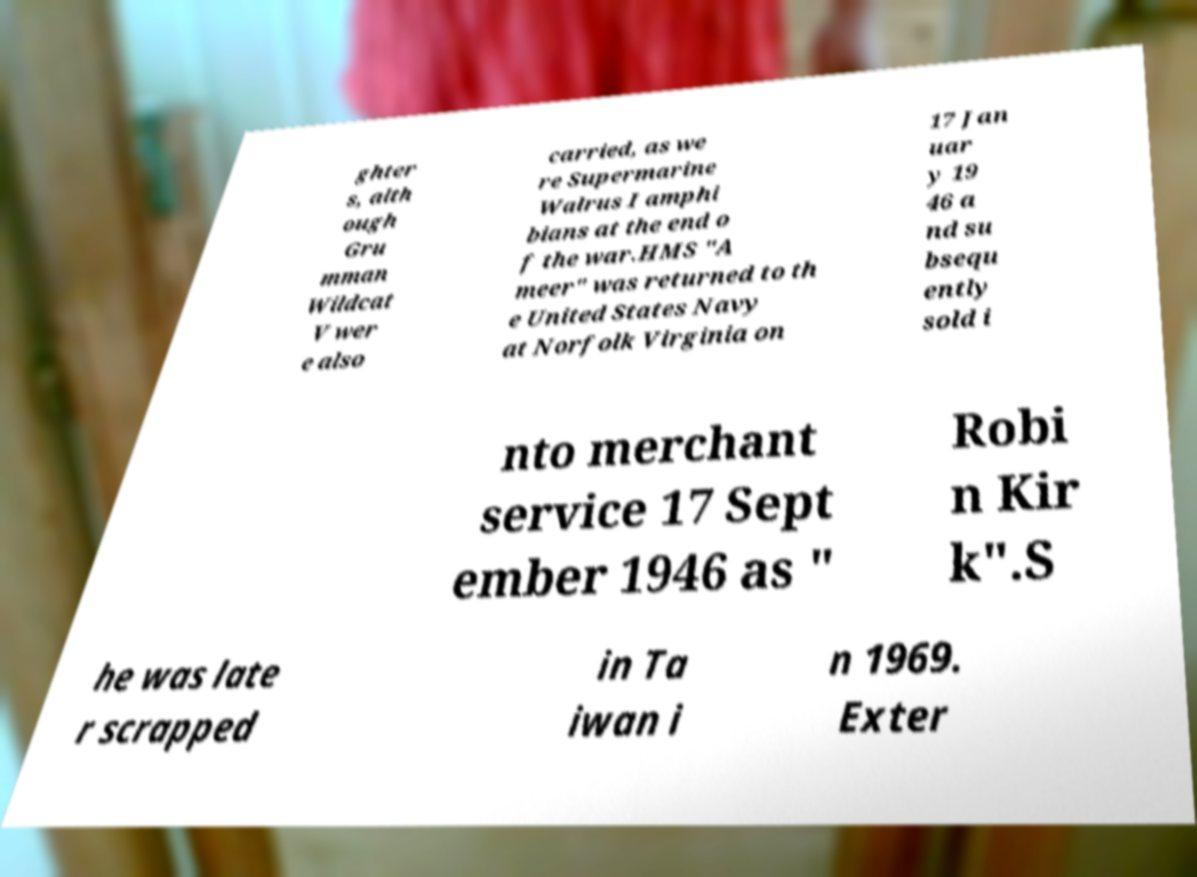For documentation purposes, I need the text within this image transcribed. Could you provide that? ghter s, alth ough Gru mman Wildcat V wer e also carried, as we re Supermarine Walrus I amphi bians at the end o f the war.HMS "A meer" was returned to th e United States Navy at Norfolk Virginia on 17 Jan uar y 19 46 a nd su bsequ ently sold i nto merchant service 17 Sept ember 1946 as " Robi n Kir k".S he was late r scrapped in Ta iwan i n 1969. Exter 